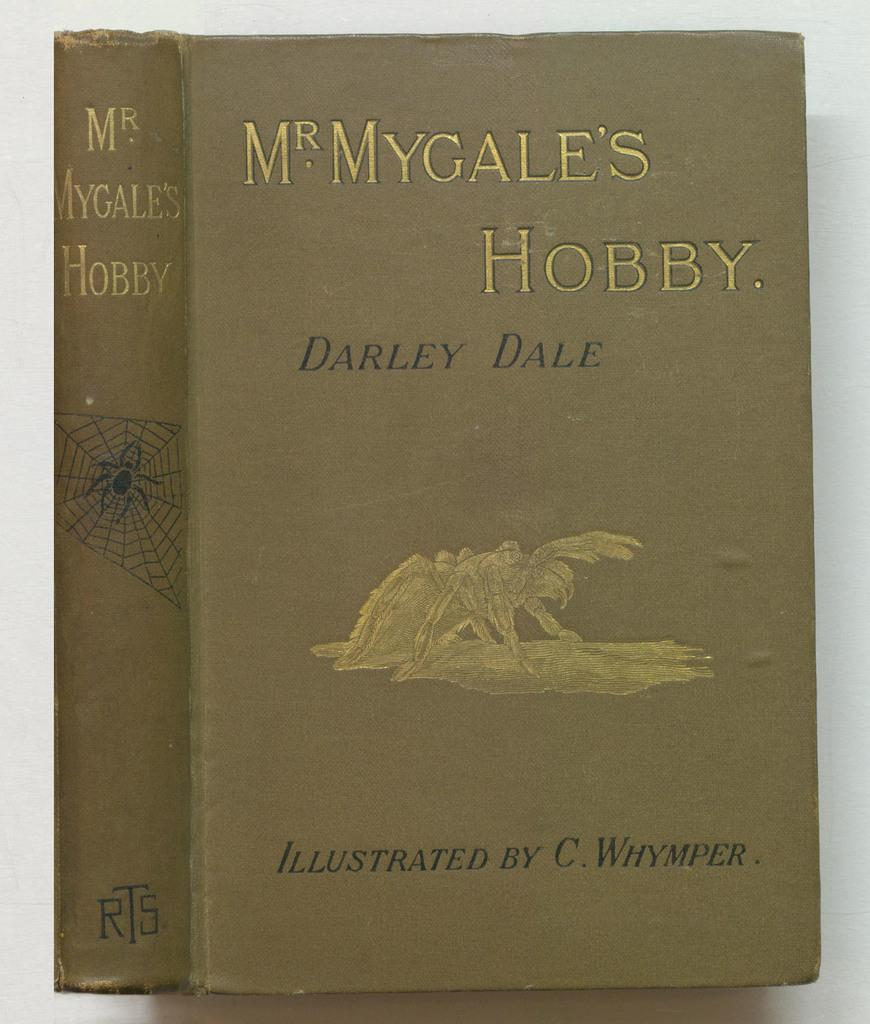Provide a one-sentence caption for the provided image. Brown book named MyGales Hobby by Darley Dale. 